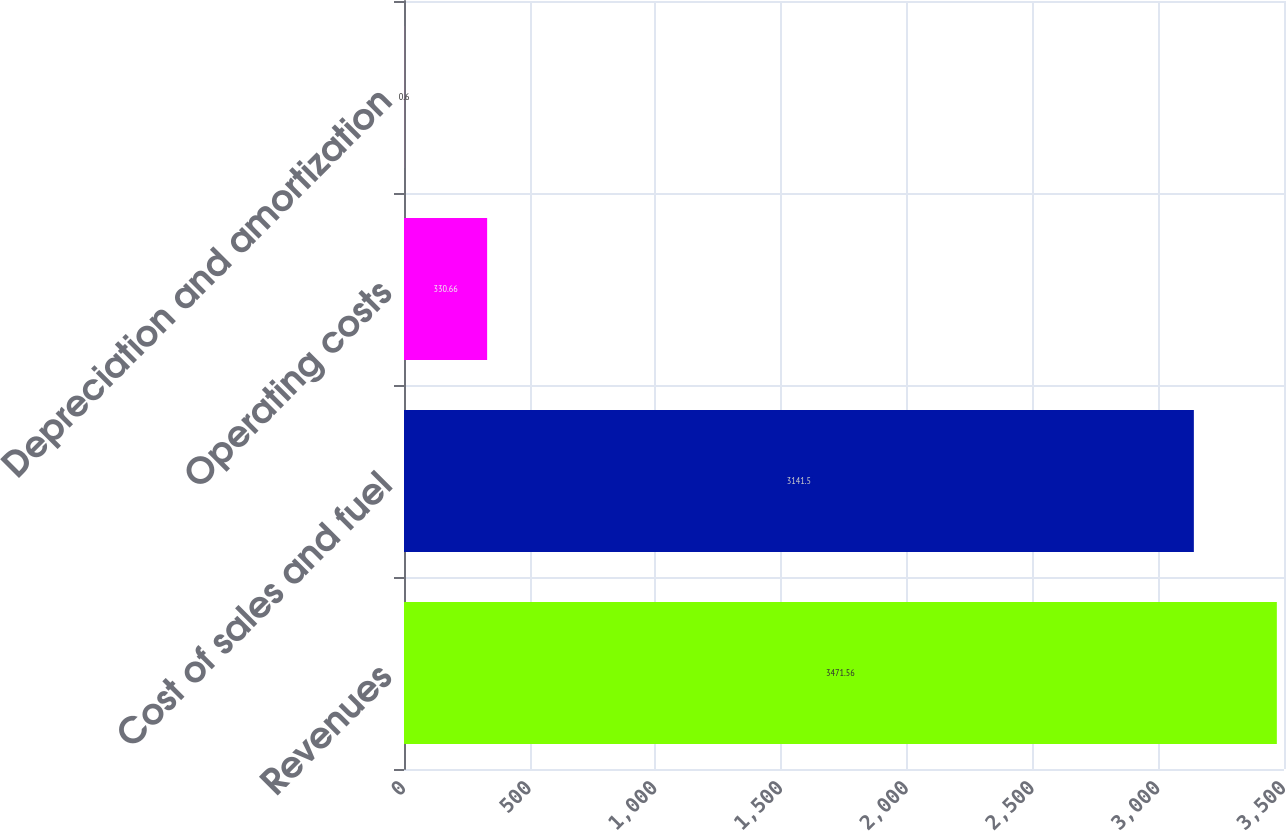Convert chart to OTSL. <chart><loc_0><loc_0><loc_500><loc_500><bar_chart><fcel>Revenues<fcel>Cost of sales and fuel<fcel>Operating costs<fcel>Depreciation and amortization<nl><fcel>3471.56<fcel>3141.5<fcel>330.66<fcel>0.6<nl></chart> 